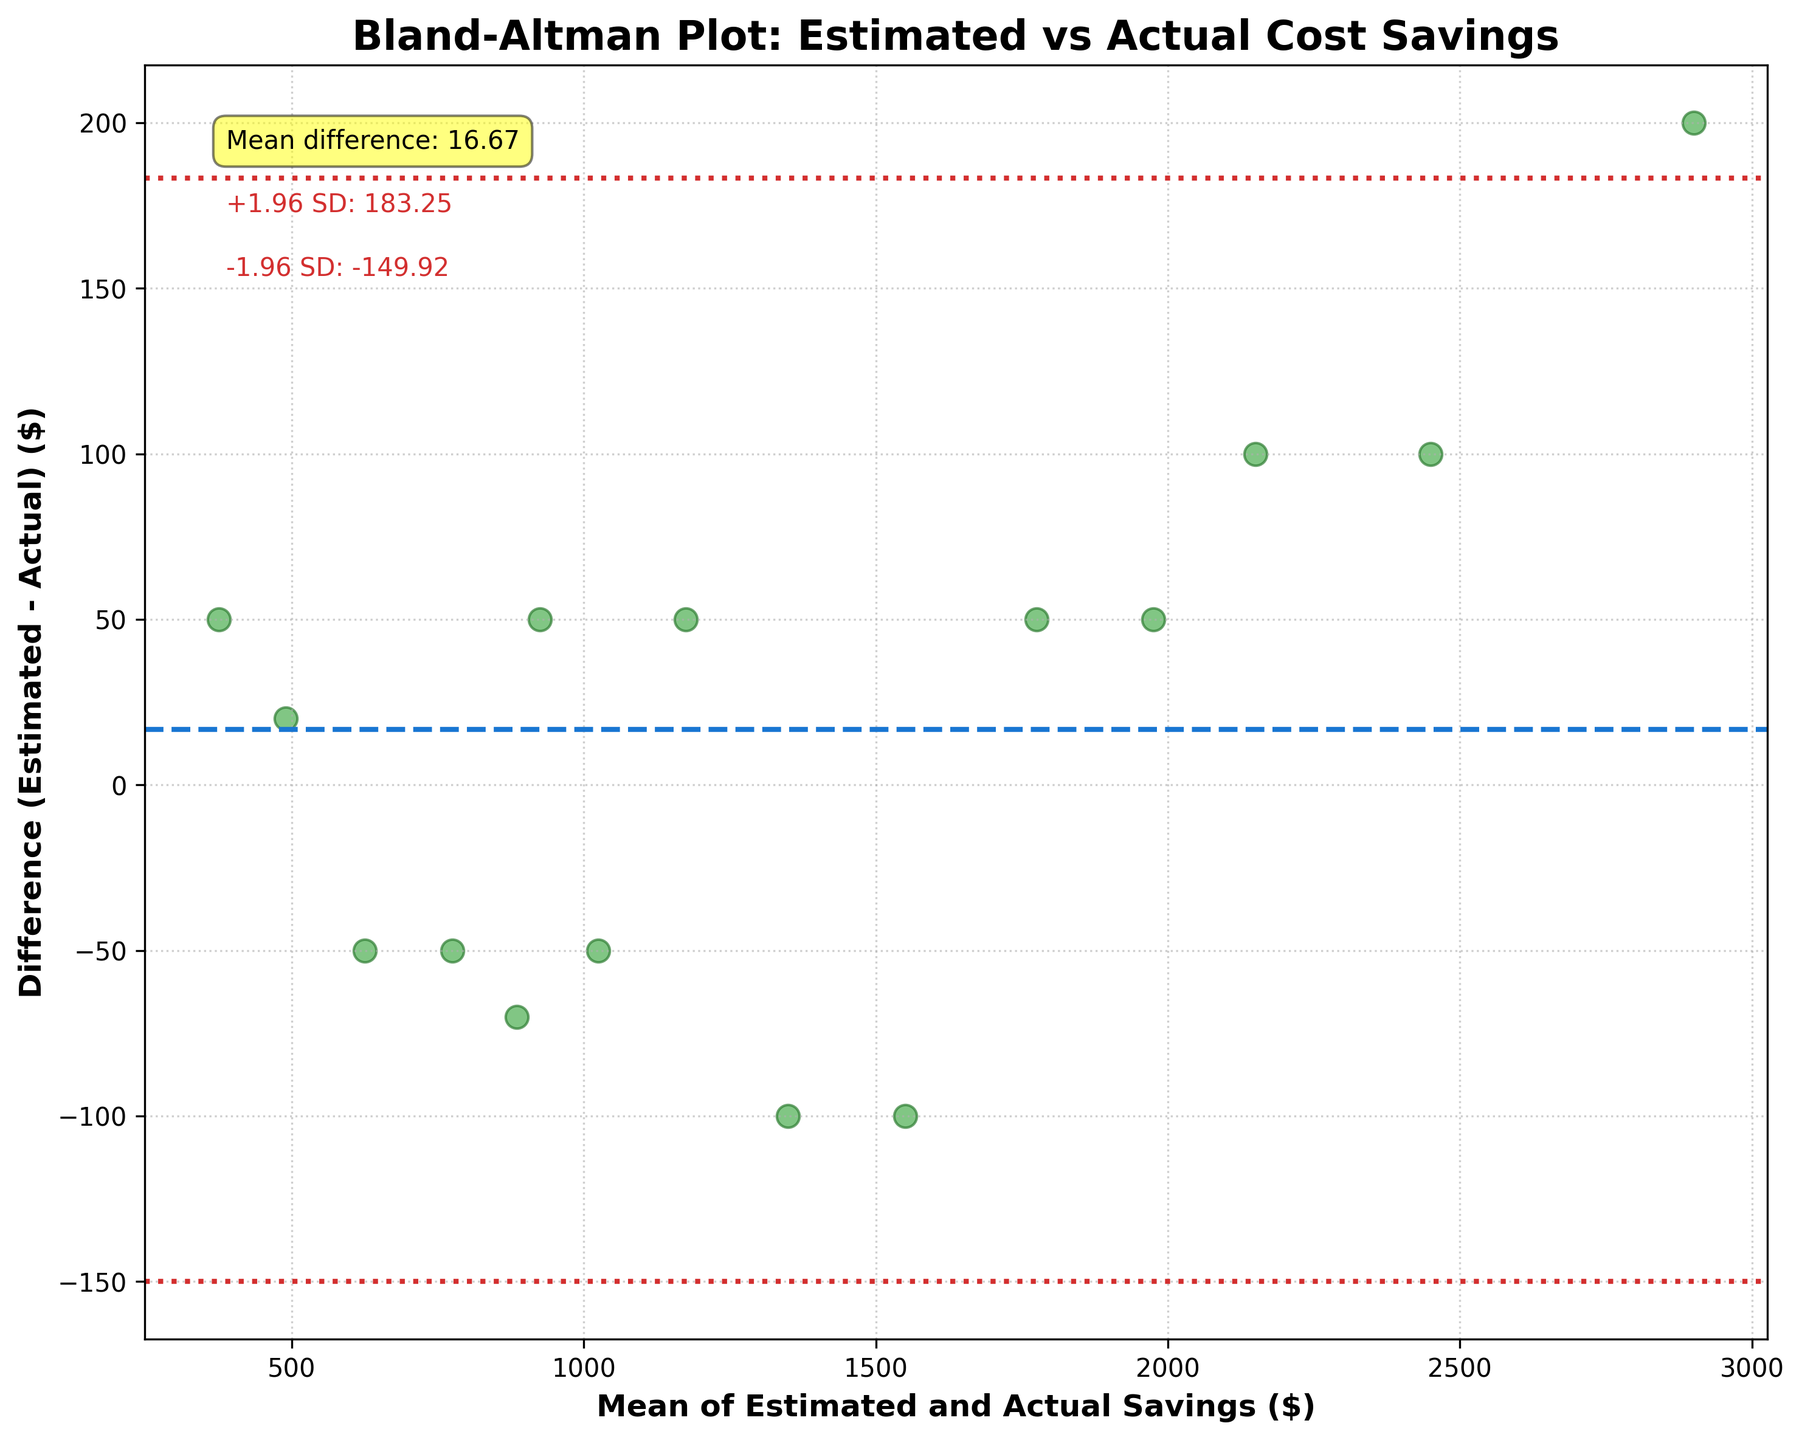How many data points are displayed in the plot? By counting the number of scattered points on the plot, we can determine there are 15 data points.
Answer: 15 What is the title of the plot? The title of the plot can be seen at the top of the figure as "Bland-Altman Plot: Estimated vs Actual Cost Savings".
Answer: Bland-Altman Plot: Estimated vs Actual Cost Savings Which color and line style represents the mean difference line? The mean difference line is represented by a dashed blue line.
Answer: Dashed blue line What is the mean of estimated and actual savings of the highest value data point? The highest value data point is when the mean of estimated and actual savings is 2900. The highest value estimated savings are $3000 and actual savings are $2800. By averaging them, (3000+2800)/2 = 2900.
Answer: 2900 What is the difference between estimated and actual savings for the point with the mean value of $2200? For the data point with a mean value of $2200, the estimated savings are $2200 and the actual savings are $2100. The difference is 2200 - 2100 = 100.
Answer: 100 What are the values of the limits of agreement (LOA) lines? The LOA lines are shown as dotted red lines, and the upper LOA is approximately 222.65, and the lower LOA is approximately -255.99. This is determined by the annotations near the top left of the plot.
Answer: 222.65 and -255.99 Which two data points have the smallest and largest differences? The smallest difference can be identified by finding the point closest to the x-axis, which is the point around mean value of $490, where the difference is 20. The largest difference is around the mean value of $2900, where the difference is about 200.
Answer: Smallest: ~20, Largest: ~200 Is the method of saving estimation accurate according to the agreement range on the plot? One way to assess accuracy is by seeing if most points lie within the limits of agreement (-255.99 to 222.65), which they do. Hence, the method appears to be reasonably accurate.
Answer: Yes Which data point signifies the most overestimated savings according to the plot? The data point with the largest positive difference indicates the most overestimated savings. This data point is around a mean value of $2900, suggesting an overestimate of around $200.
Answer: Mean value ~2900 